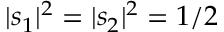<formula> <loc_0><loc_0><loc_500><loc_500>| s _ { 1 } | ^ { 2 } = | s _ { 2 } | ^ { 2 } = 1 / 2</formula> 